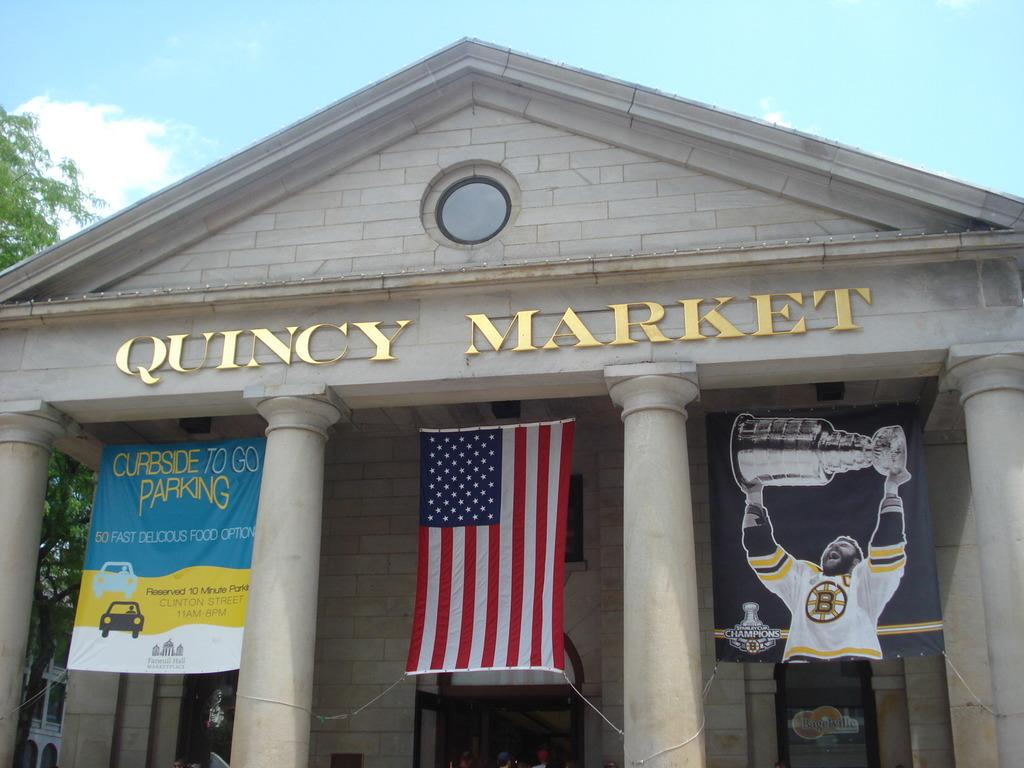<image>
Write a terse but informative summary of the picture. An american flag hangs in the center of the Quincy Market building with a Curbside to go Parking and Boston Bruins flag by it. 